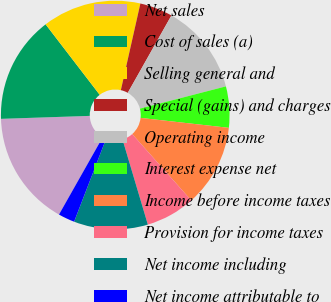Convert chart. <chart><loc_0><loc_0><loc_500><loc_500><pie_chart><fcel>Net sales<fcel>Cost of sales (a)<fcel>Selling general and<fcel>Special (gains) and charges<fcel>Operating income<fcel>Interest expense net<fcel>Income before income taxes<fcel>Provision for income taxes<fcel>Net income including<fcel>Net income attributable to<nl><fcel>16.28%<fcel>15.11%<fcel>13.95%<fcel>4.65%<fcel>12.79%<fcel>5.82%<fcel>11.63%<fcel>6.98%<fcel>10.46%<fcel>2.33%<nl></chart> 